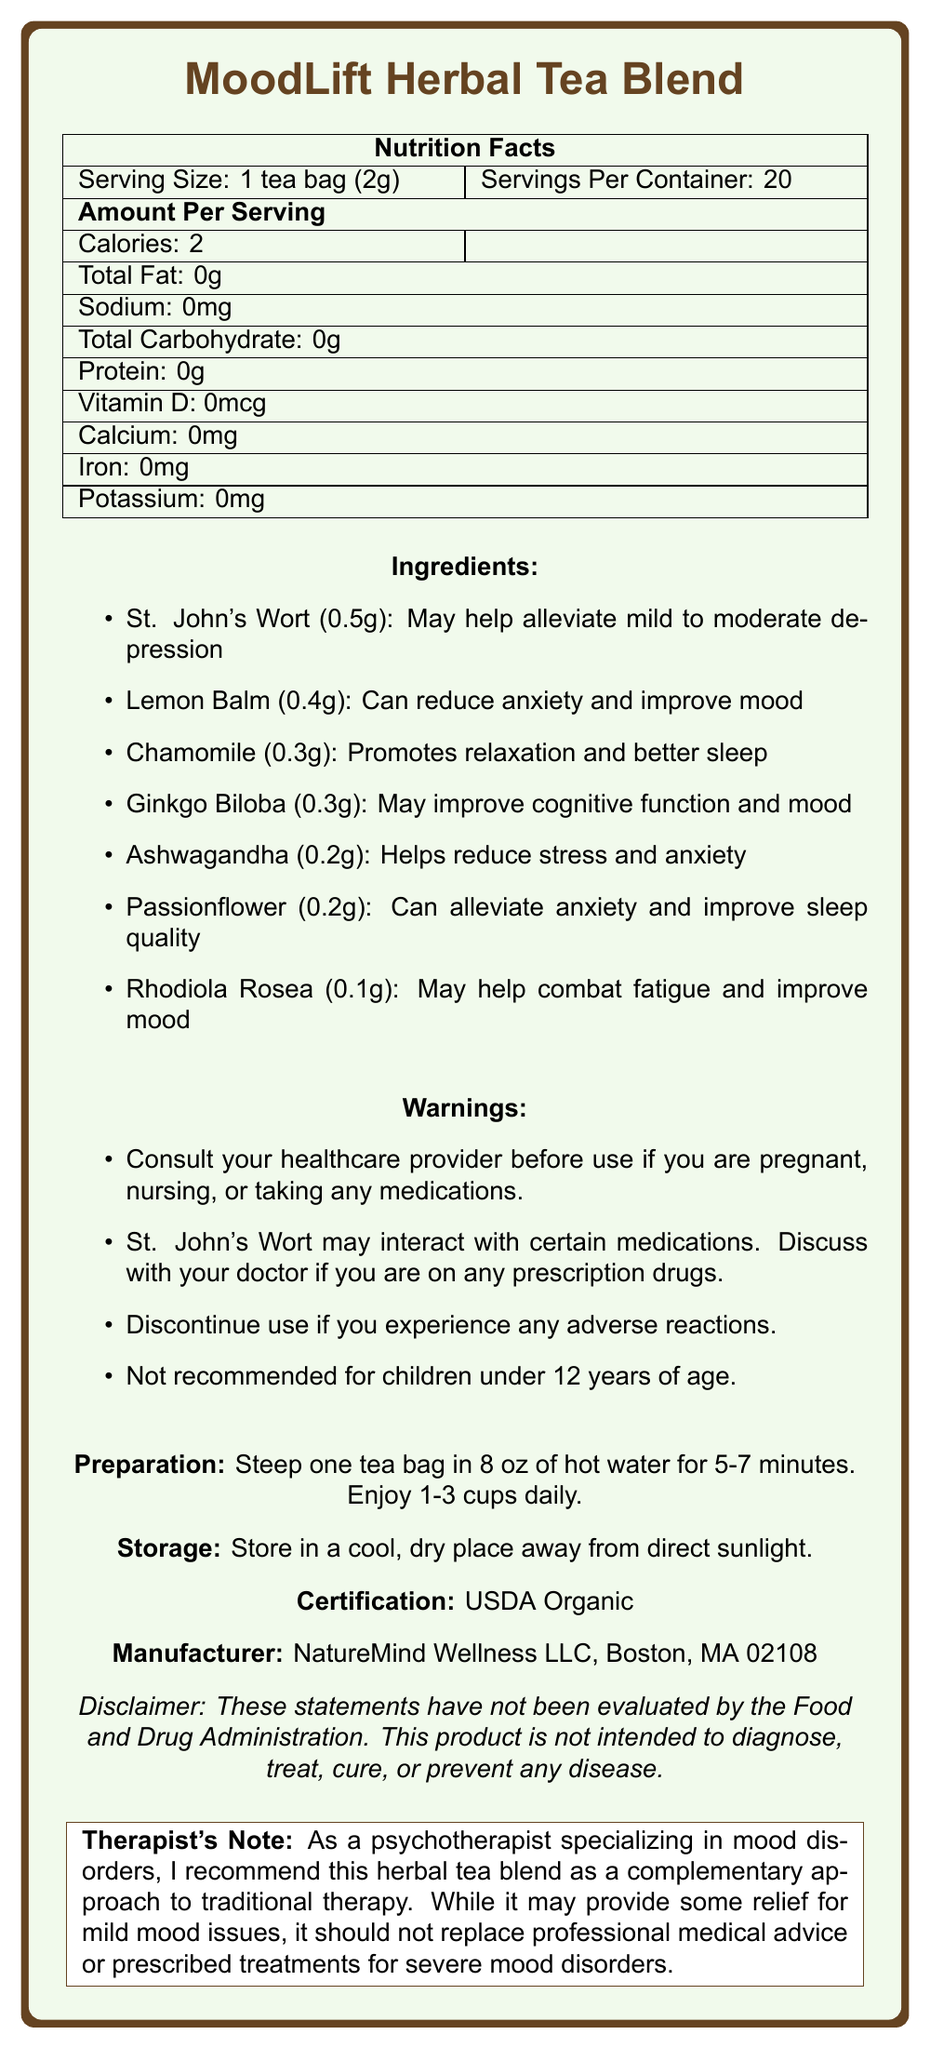what is the serving size for one tea bag? The serving size is clearly listed as "1 tea bag (2g)" in the Nutrition Facts section.
Answer: 1 tea bag (2g) how many calories are in one serving of MoodLift Herbal Tea Blend? The number of calories per serving is specified as 2 calories in the Nutrition Facts section.
Answer: 2 calories which ingredient is included in the largest amount? The ingredient list shows that St. John's Wort is included in the largest amount at 0.5g.
Answer: St. John's Wort how should the MoodLift Herbal Tea Blend be prepared? The preparation instructions provide this specific method of preparing the tea.
Answer: Steep one tea bag in 8 oz of hot water for 5-7 minutes. Enjoy 1-3 cups daily. how many tea bags are there in one container? The label states there are 20 servings per container, implying there are 20 tea bags.
Answer: 20 if you are taking prescription medications, which ingredient should you be cautious about? The warnings section advises consulting a healthcare provider if you are on medications due to potential interactions with St. John's Wort.
Answer: St. John's Wort what certifications does the MoodLift Herbal Tea Blend have? The certification section confirms that the product is USDA Organic.
Answer: USDA Organic what is the benefit of Lemon Balm listed on the document? The benefit of Lemon Balm is specified as reducing anxiety and improving mood in the ingredients list.
Answer: Can reduce anxiety and improve mood which ingredient helps to combat fatigue and improve mood? The listed benefit of Rhodiola Rosea is that it may help combat fatigue and improve mood.
Answer: Rhodiola Rosea what should you do if you experience adverse reactions to the MoodLift Herbal Tea Blend? The warnings section advises discontinuing use if any adverse reactions occur.
Answer: Discontinue use which of the following is NOT an ingredient in MoodLift Herbal Tea Blend? A. Chamomile B. Lavender C. Passionflower D. Lemon Balm The document does not list Lavender as an ingredient, while the others are included.
Answer: B. Lavender where is NatureMind Wellness LLC located? A. New York B. Boston C. Los Angeles D. Seattle The manufacturer information lists NatureMind Wellness LLC in Boston, MA 02108.
Answer: B. Boston does St. John's Wort promote relaxation and better sleep? The document states that St. John's Wort "may help alleviate mild to moderate depression" and does not mention it promoting relaxation and better sleep.
Answer: No is the MoodLift Herbal Tea Blend recommended for children under 12 years of age? The warnings section clearly states it is not recommended for children under 12 years of age.
Answer: No summarize the key points of the MoodLift Herbal Tea Blend nutrition label. This summary covers the main aspects and information provided on the document regarding the product, ingredients, benefits, warnings, and preparation.
Answer: The MoodLift Herbal Tea Blend is an herbal tea with mood-boosting ingredients. One tea bag, serving size (2g), contains 2 calories and no fat, sodium, carbohydrates, protein, vitamin D, calcium, iron, or potassium. Key ingredients include St. John's Wort, Lemon Balm, Chamomile, Ginkgo Biloba, Ashwagandha, Passionflower, and Rhodiola Rosea, which offer benefits such as alleviating depression, reducing anxiety, promoting relaxation, and improving mood. The product has warnings about potential interactions and adverse reactions, is certified USDA Organic, and is manufactured by NatureMind Wellness LLC in Boston, MA. Preparation involves steeping a tea bag in hot water for 5-7 minutes and consuming 1-3 cups daily. how many grams of protein are in one serving? The Nutrition Facts section lists the protein content as 0 grams per serving.
Answer: 0 what is the address of the manufacturer? The document states the manufacturer's location as Boston, MA 02108 but does not provide a full address with a street name or number.
Answer: Not enough information 